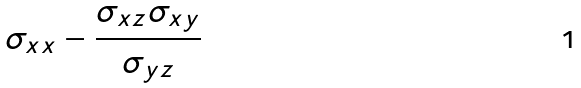<formula> <loc_0><loc_0><loc_500><loc_500>\sigma _ { x x } - \frac { \sigma _ { x z } \sigma _ { x y } } { \sigma _ { y z } }</formula> 